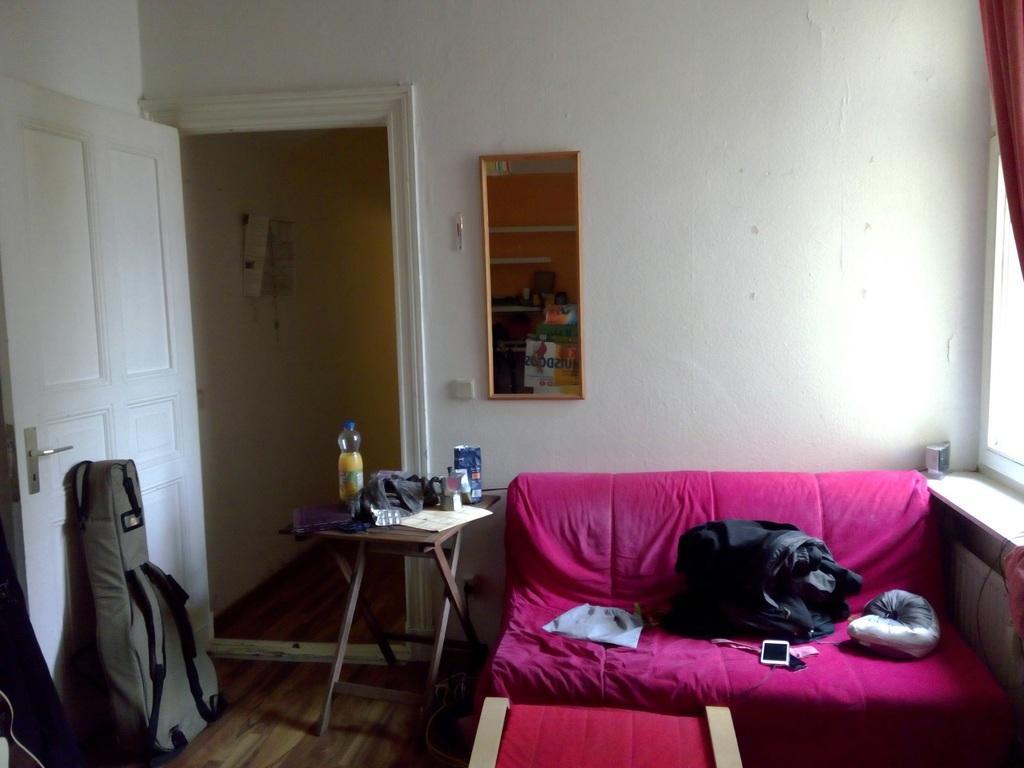How would you summarize this image in a sentence or two? The image is clicked inside a room. To the right, there is a sofa, on which a dog is sleeping and mobile, jacket, and a cloth are kept. In the background there is a door, wall and a rack. To the left, there is a guitar bag. In the front, there is a small table. 